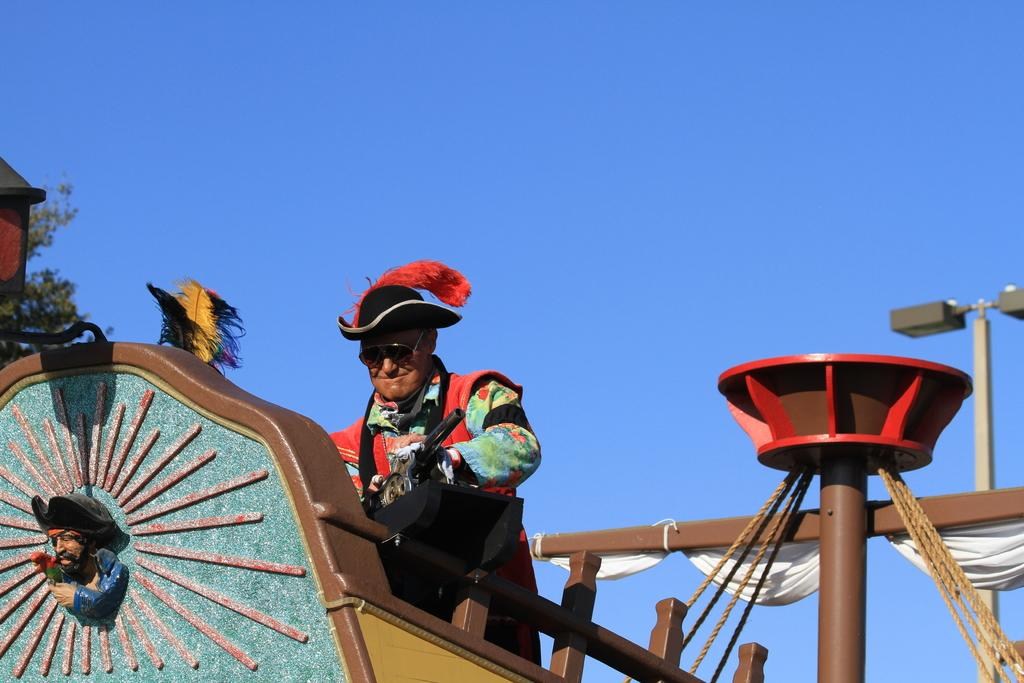What is the main subject of the image? The main subject of the image is a pirate ship. Can you describe the person standing in the pirate ship? There is a person standing in the pirate ship, but their appearance or role cannot be determined from the image. What is visible in the background of the image? The background of the image includes a blue sky. What type of paste is being used by the creature in the image? There is no creature or paste present in the image; it features a pirate ship and a person standing in it. 